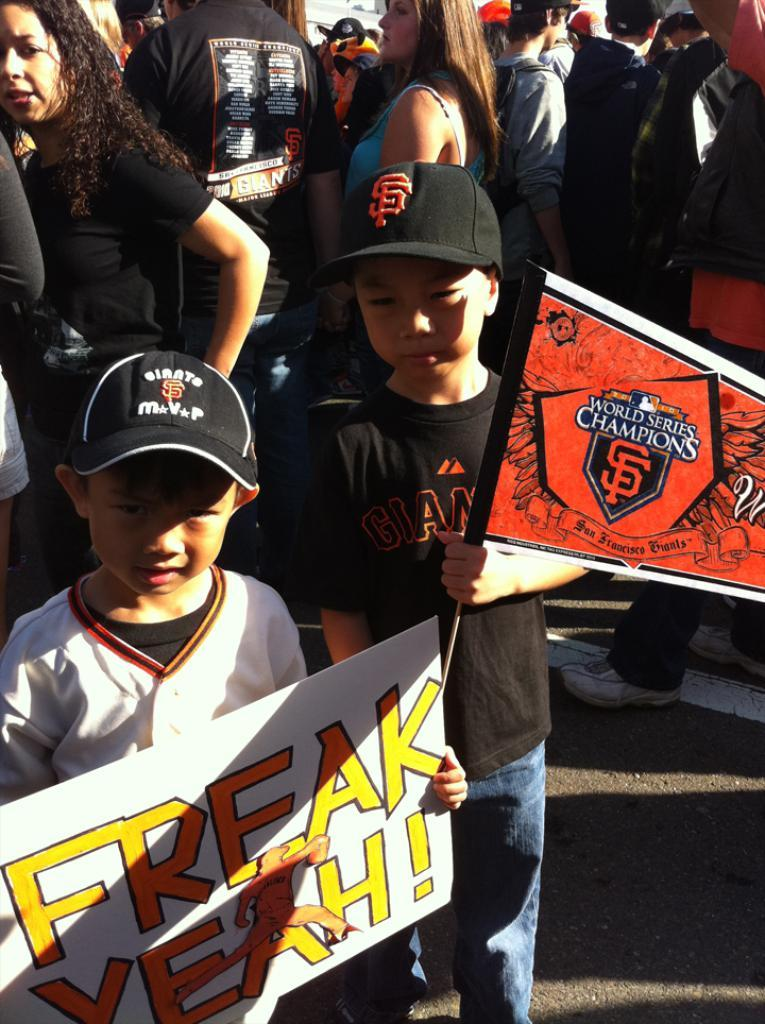<image>
Write a terse but informative summary of the picture. A small boy in a black hat holds up a poster that has FREAK YEAH written on it. 